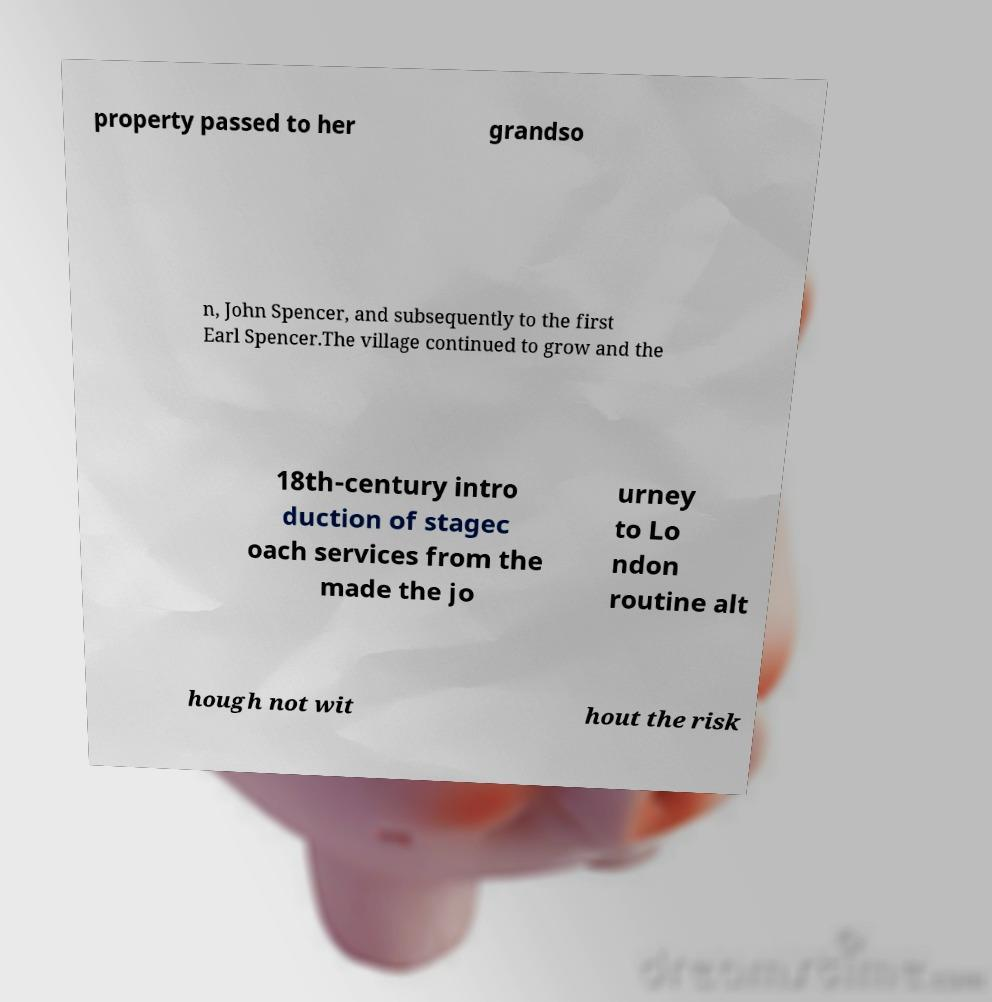What messages or text are displayed in this image? I need them in a readable, typed format. property passed to her grandso n, John Spencer, and subsequently to the first Earl Spencer.The village continued to grow and the 18th-century intro duction of stagec oach services from the made the jo urney to Lo ndon routine alt hough not wit hout the risk 